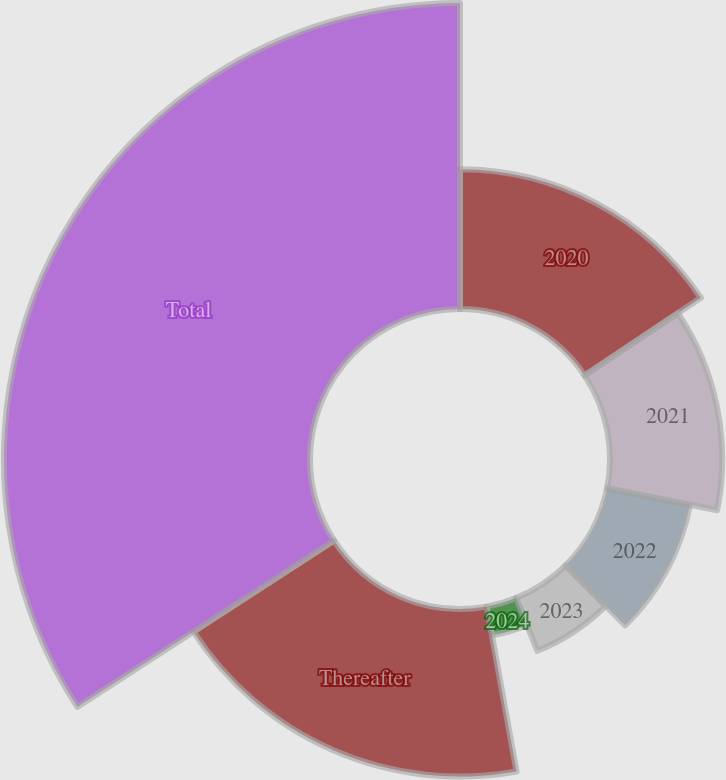<chart> <loc_0><loc_0><loc_500><loc_500><pie_chart><fcel>2020<fcel>2021<fcel>2022<fcel>2023<fcel>2024<fcel>Thereafter<fcel>Total<nl><fcel>15.61%<fcel>12.52%<fcel>9.43%<fcel>6.34%<fcel>3.25%<fcel>18.7%<fcel>34.15%<nl></chart> 